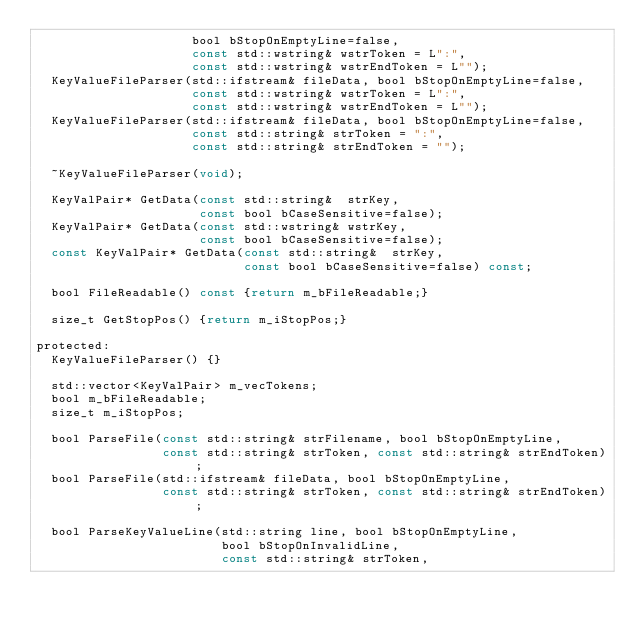<code> <loc_0><loc_0><loc_500><loc_500><_C_>                     bool bStopOnEmptyLine=false,
                     const std::wstring& wstrToken = L":",
                     const std::wstring& wstrEndToken = L"");
  KeyValueFileParser(std::ifstream& fileData, bool bStopOnEmptyLine=false,
                     const std::wstring& wstrToken = L":",
                     const std::wstring& wstrEndToken = L"");
  KeyValueFileParser(std::ifstream& fileData, bool bStopOnEmptyLine=false,
                     const std::string& strToken = ":",
                     const std::string& strEndToken = "");

  ~KeyValueFileParser(void);

  KeyValPair* GetData(const std::string&  strKey,
                      const bool bCaseSensitive=false);
  KeyValPair* GetData(const std::wstring& wstrKey,
                      const bool bCaseSensitive=false);
  const KeyValPair* GetData(const std::string&  strKey,
                            const bool bCaseSensitive=false) const;

  bool FileReadable() const {return m_bFileReadable;}

  size_t GetStopPos() {return m_iStopPos;}

protected:
  KeyValueFileParser() {}

  std::vector<KeyValPair> m_vecTokens;
  bool m_bFileReadable;
  size_t m_iStopPos;

  bool ParseFile(const std::string& strFilename, bool bStopOnEmptyLine,
                 const std::string& strToken, const std::string& strEndToken);
  bool ParseFile(std::ifstream& fileData, bool bStopOnEmptyLine,
                 const std::string& strToken, const std::string& strEndToken);

  bool ParseKeyValueLine(std::string line, bool bStopOnEmptyLine,
                         bool bStopOnInvalidLine,
                         const std::string& strToken,</code> 